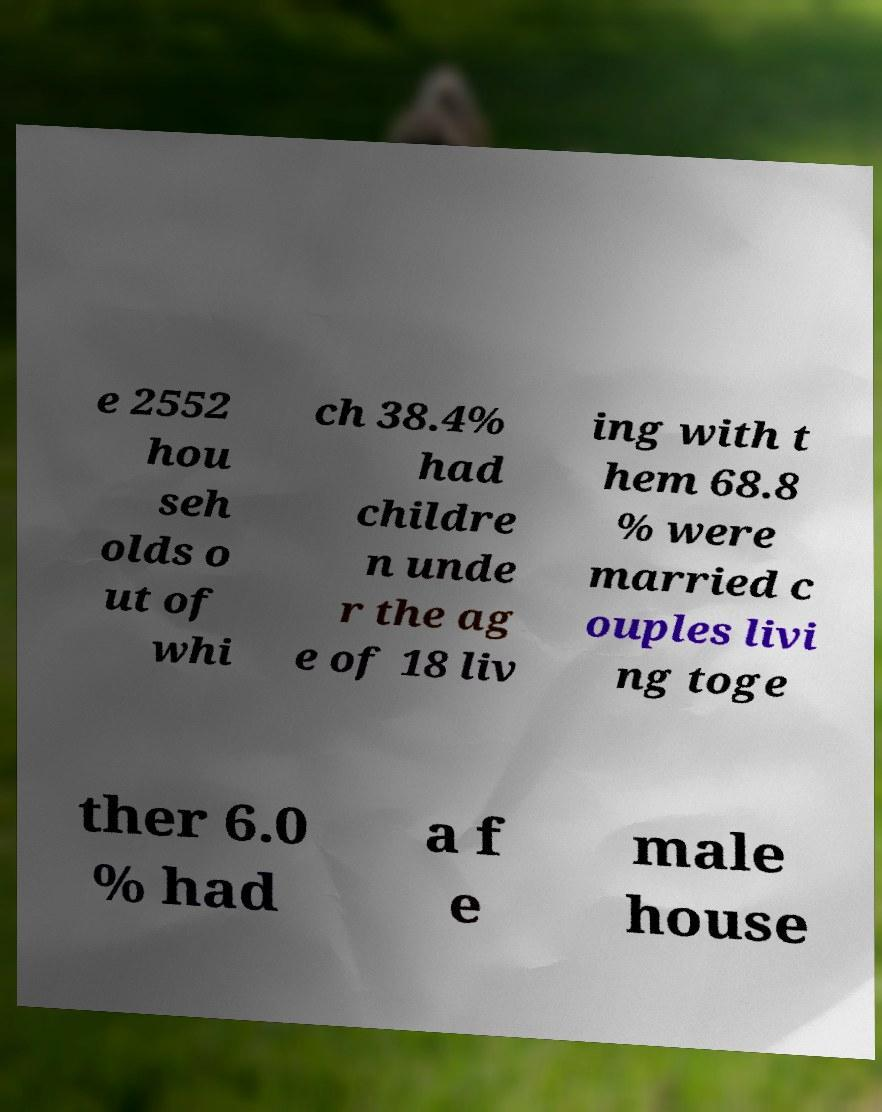Please read and relay the text visible in this image. What does it say? e 2552 hou seh olds o ut of whi ch 38.4% had childre n unde r the ag e of 18 liv ing with t hem 68.8 % were married c ouples livi ng toge ther 6.0 % had a f e male house 